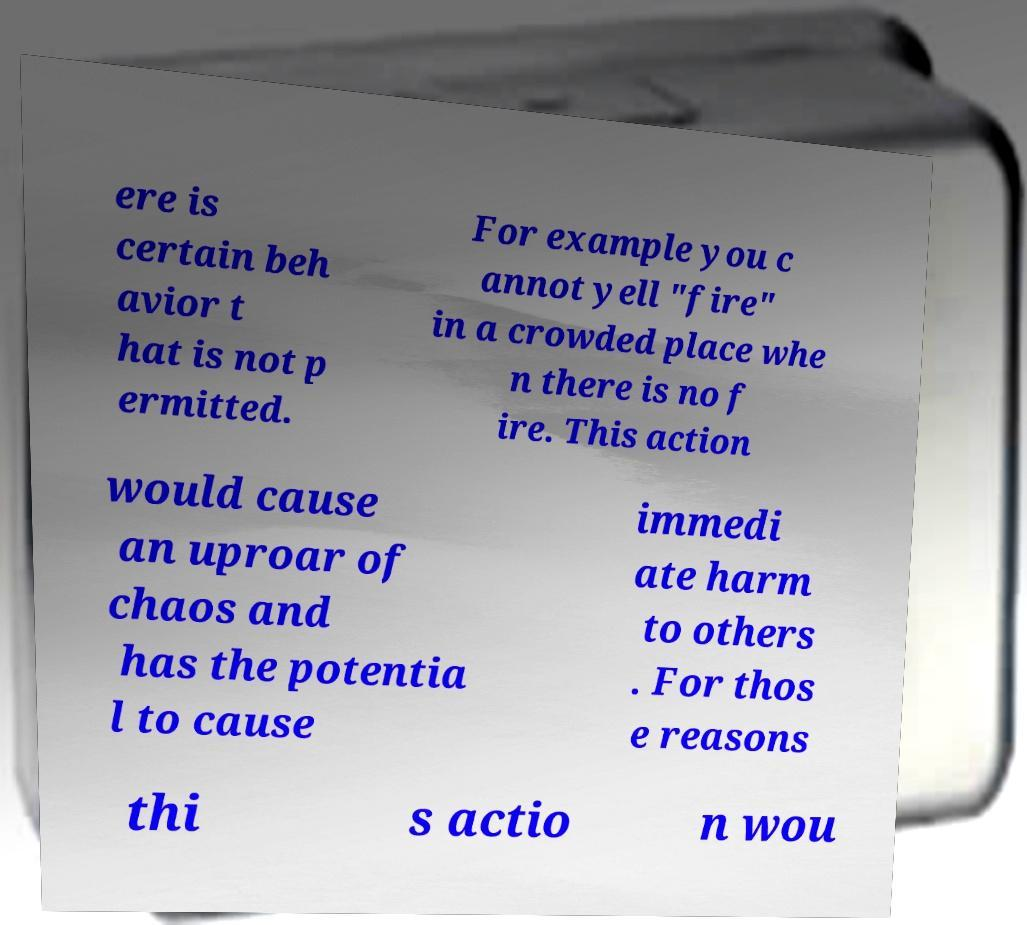Can you read and provide the text displayed in the image?This photo seems to have some interesting text. Can you extract and type it out for me? ere is certain beh avior t hat is not p ermitted. For example you c annot yell "fire" in a crowded place whe n there is no f ire. This action would cause an uproar of chaos and has the potentia l to cause immedi ate harm to others . For thos e reasons thi s actio n wou 